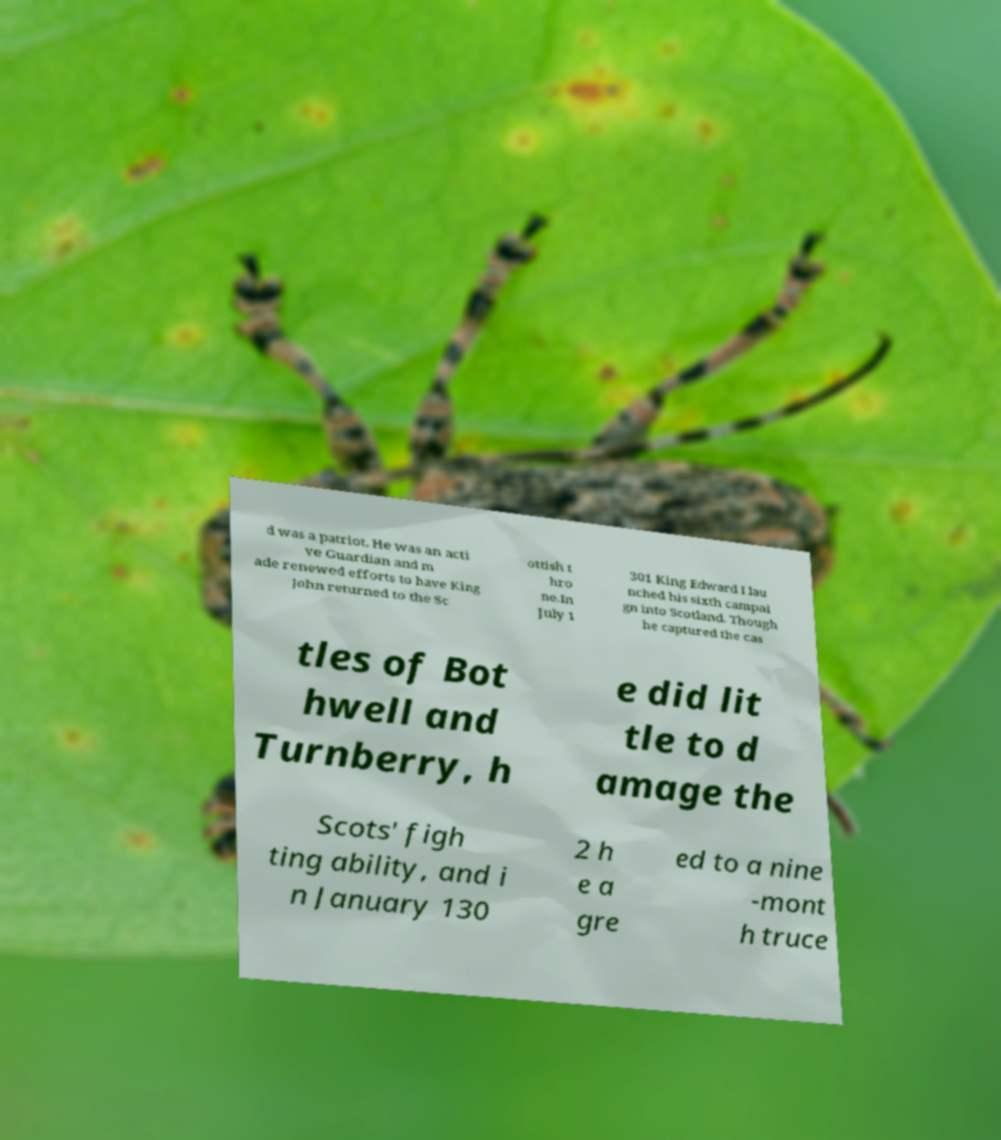I need the written content from this picture converted into text. Can you do that? d was a patriot. He was an acti ve Guardian and m ade renewed efforts to have King John returned to the Sc ottish t hro ne.In July 1 301 King Edward I lau nched his sixth campai gn into Scotland. Though he captured the cas tles of Bot hwell and Turnberry, h e did lit tle to d amage the Scots' figh ting ability, and i n January 130 2 h e a gre ed to a nine -mont h truce 